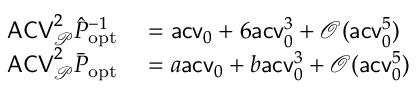<formula> <loc_0><loc_0><loc_500><loc_500>\begin{array} { r l } { A C V _ { \mathcal { P } } ^ { 2 } \hat { P } _ { o p t } ^ { - 1 } } & = a c v _ { 0 } + 6 a c v _ { 0 } ^ { 3 } + \mathcal { O } ( a c v _ { 0 } ^ { 5 } ) } \\ { A C V _ { \mathcal { P } } ^ { 2 } \bar { P } _ { o p t } } & = a a c v _ { 0 } + b a c v _ { 0 } ^ { 3 } + \mathcal { O } ( a c v _ { 0 } ^ { 5 } ) } \end{array}</formula> 